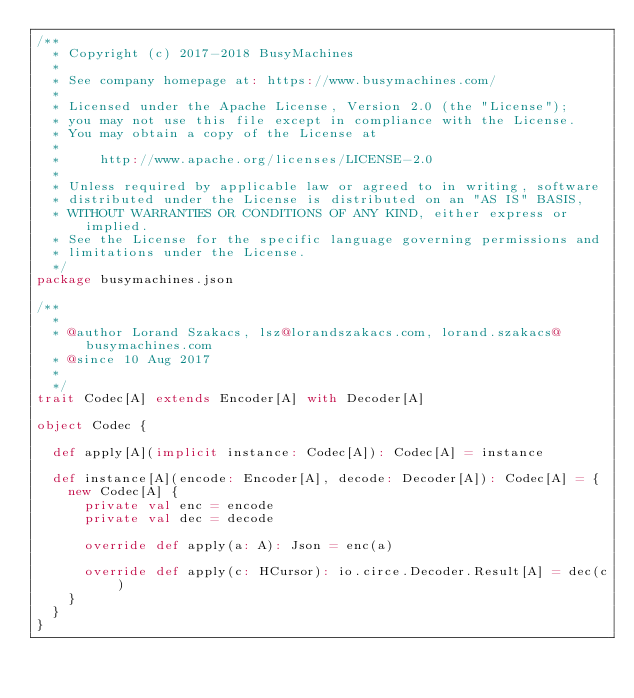<code> <loc_0><loc_0><loc_500><loc_500><_Scala_>/**
  * Copyright (c) 2017-2018 BusyMachines
  *
  * See company homepage at: https://www.busymachines.com/
  *
  * Licensed under the Apache License, Version 2.0 (the "License");
  * you may not use this file except in compliance with the License.
  * You may obtain a copy of the License at
  *
  *     http://www.apache.org/licenses/LICENSE-2.0
  *
  * Unless required by applicable law or agreed to in writing, software
  * distributed under the License is distributed on an "AS IS" BASIS,
  * WITHOUT WARRANTIES OR CONDITIONS OF ANY KIND, either express or implied.
  * See the License for the specific language governing permissions and
  * limitations under the License.
  */
package busymachines.json

/**
  *
  * @author Lorand Szakacs, lsz@lorandszakacs.com, lorand.szakacs@busymachines.com
  * @since 10 Aug 2017
  *
  */
trait Codec[A] extends Encoder[A] with Decoder[A]

object Codec {

  def apply[A](implicit instance: Codec[A]): Codec[A] = instance

  def instance[A](encode: Encoder[A], decode: Decoder[A]): Codec[A] = {
    new Codec[A] {
      private val enc = encode
      private val dec = decode

      override def apply(a: A): Json = enc(a)

      override def apply(c: HCursor): io.circe.Decoder.Result[A] = dec(c)
    }
  }
}
</code> 